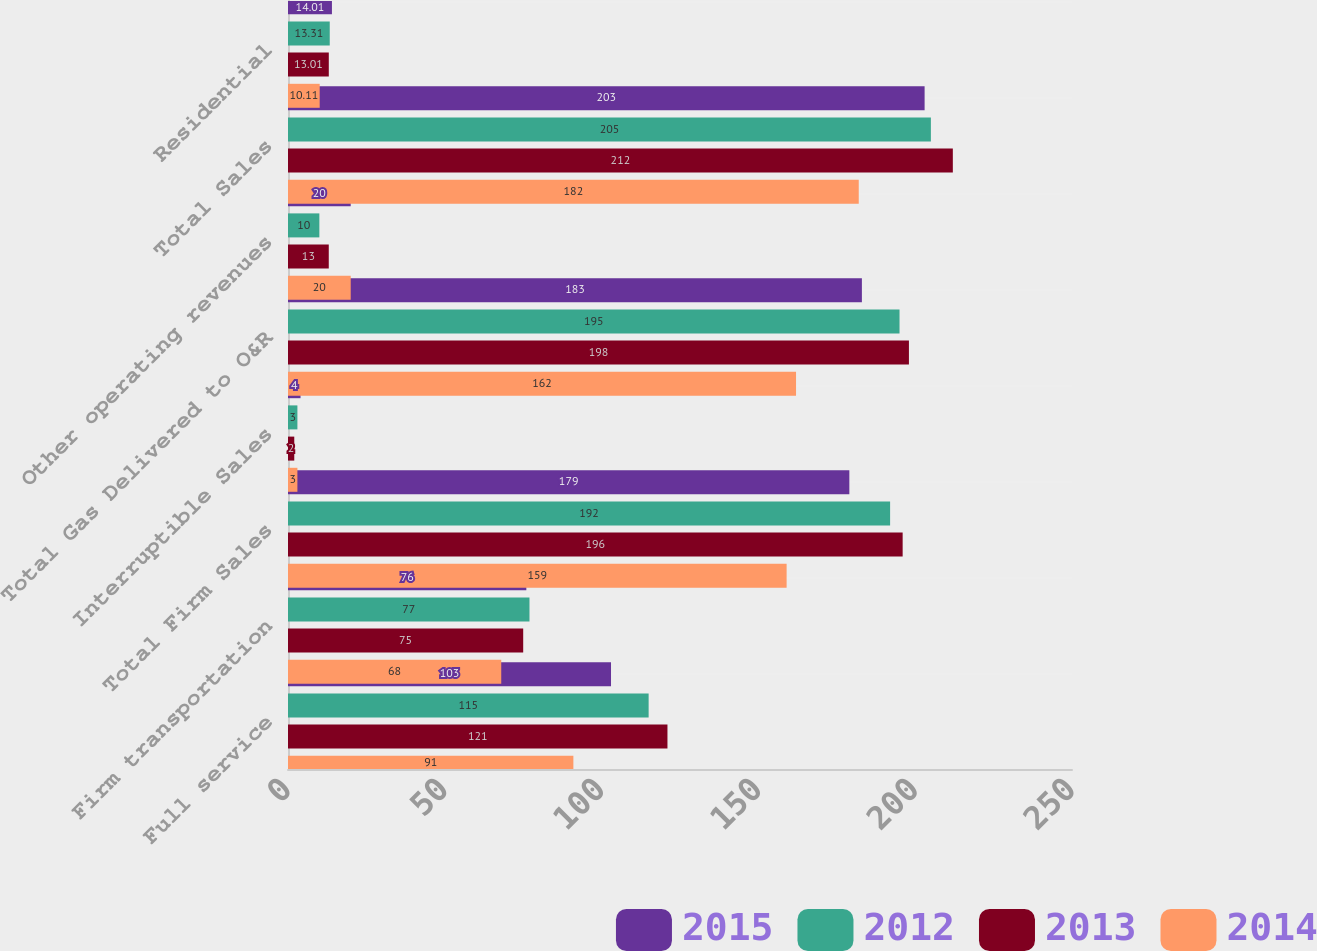Convert chart. <chart><loc_0><loc_0><loc_500><loc_500><stacked_bar_chart><ecel><fcel>Full service<fcel>Firm transportation<fcel>Total Firm Sales<fcel>Interruptible Sales<fcel>Total Gas Delivered to O&R<fcel>Other operating revenues<fcel>Total Sales<fcel>Residential<nl><fcel>2015<fcel>103<fcel>76<fcel>179<fcel>4<fcel>183<fcel>20<fcel>203<fcel>14.01<nl><fcel>2012<fcel>115<fcel>77<fcel>192<fcel>3<fcel>195<fcel>10<fcel>205<fcel>13.31<nl><fcel>2013<fcel>121<fcel>75<fcel>196<fcel>2<fcel>198<fcel>13<fcel>212<fcel>13.01<nl><fcel>2014<fcel>91<fcel>68<fcel>159<fcel>3<fcel>162<fcel>20<fcel>182<fcel>10.11<nl></chart> 